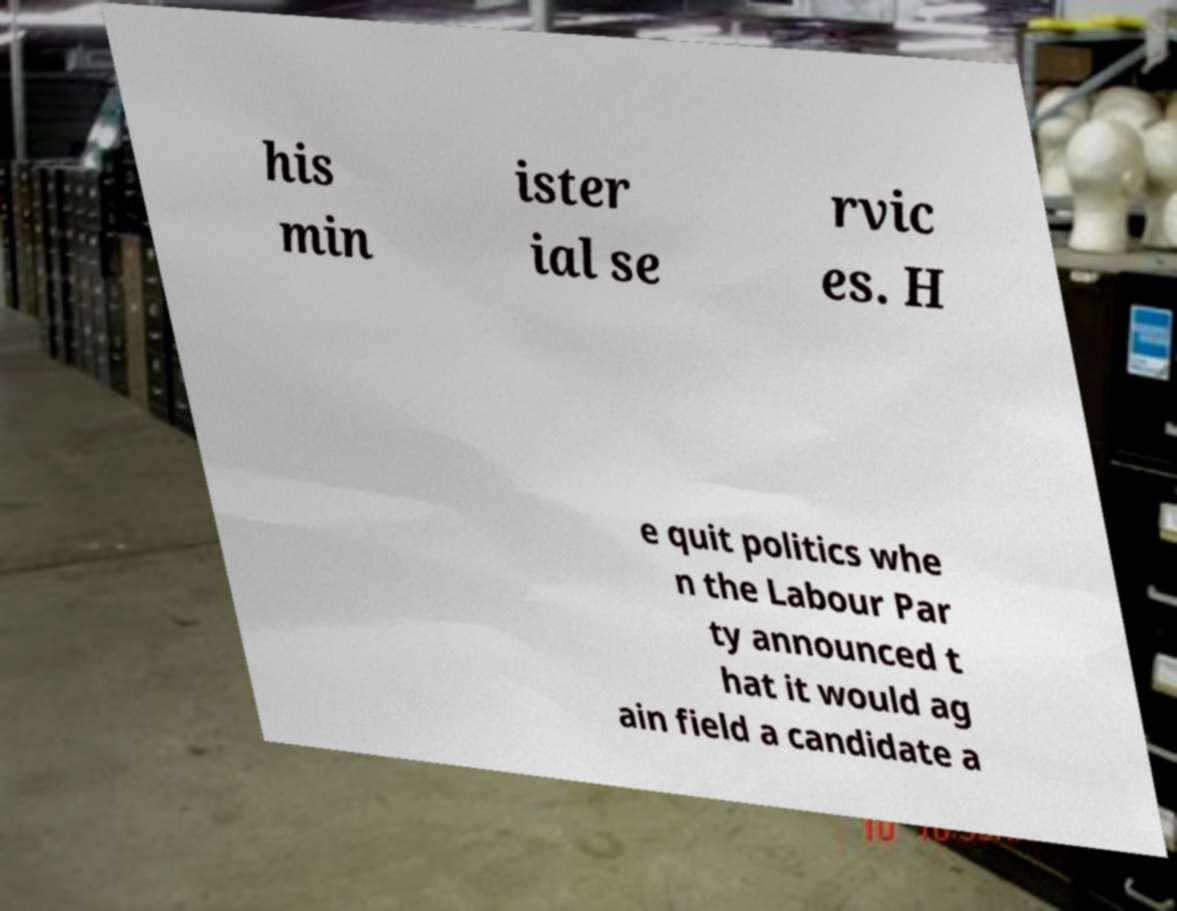There's text embedded in this image that I need extracted. Can you transcribe it verbatim? his min ister ial se rvic es. H e quit politics whe n the Labour Par ty announced t hat it would ag ain field a candidate a 